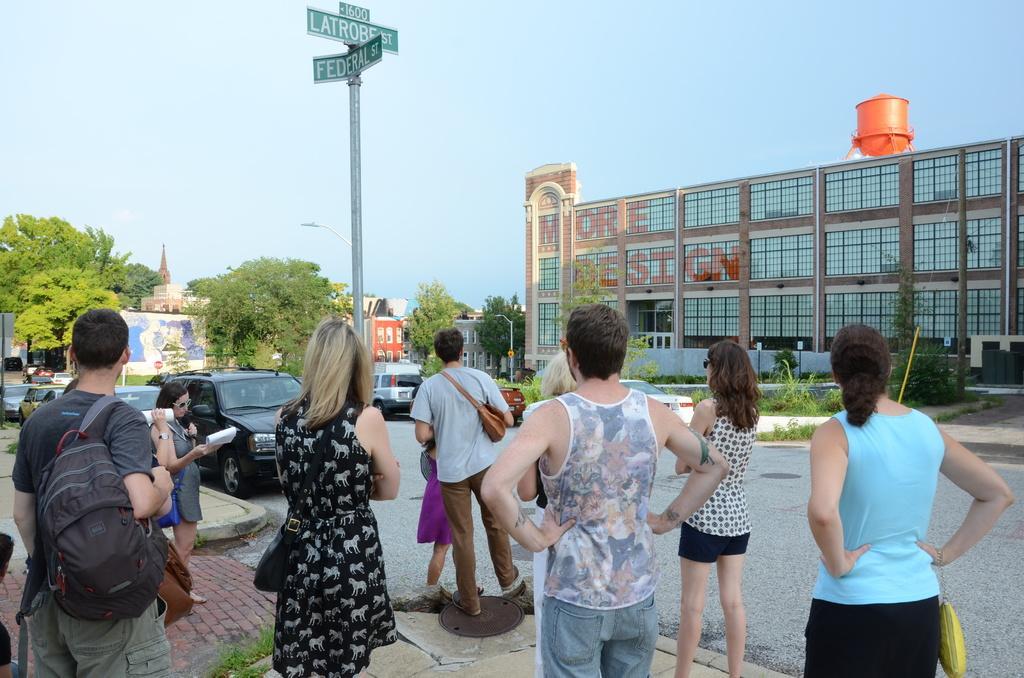In one or two sentences, can you explain what this image depicts? In this image we can see some people standing and there are some vehicles on the road. We can see some buildings, trees and plants. There is a sidewalk and a pole with sign boards with some text on it and there is a board on the ground. 